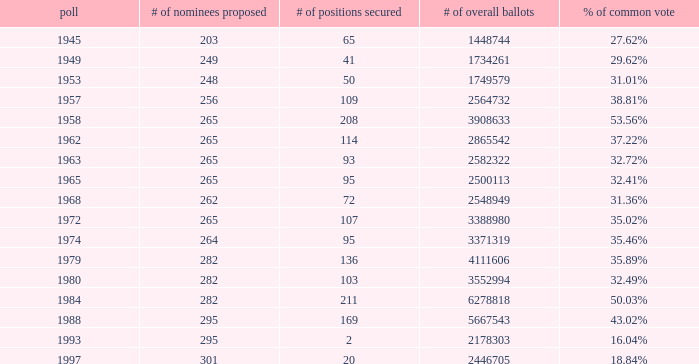What was the lowest # of total votes? 1448744.0. 